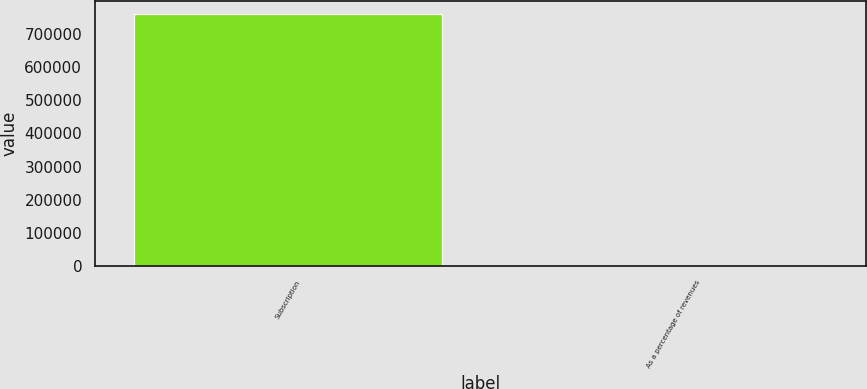Convert chart. <chart><loc_0><loc_0><loc_500><loc_500><bar_chart><fcel>Subscription<fcel>As a percentage of revenues<nl><fcel>761133<fcel>55.8<nl></chart> 